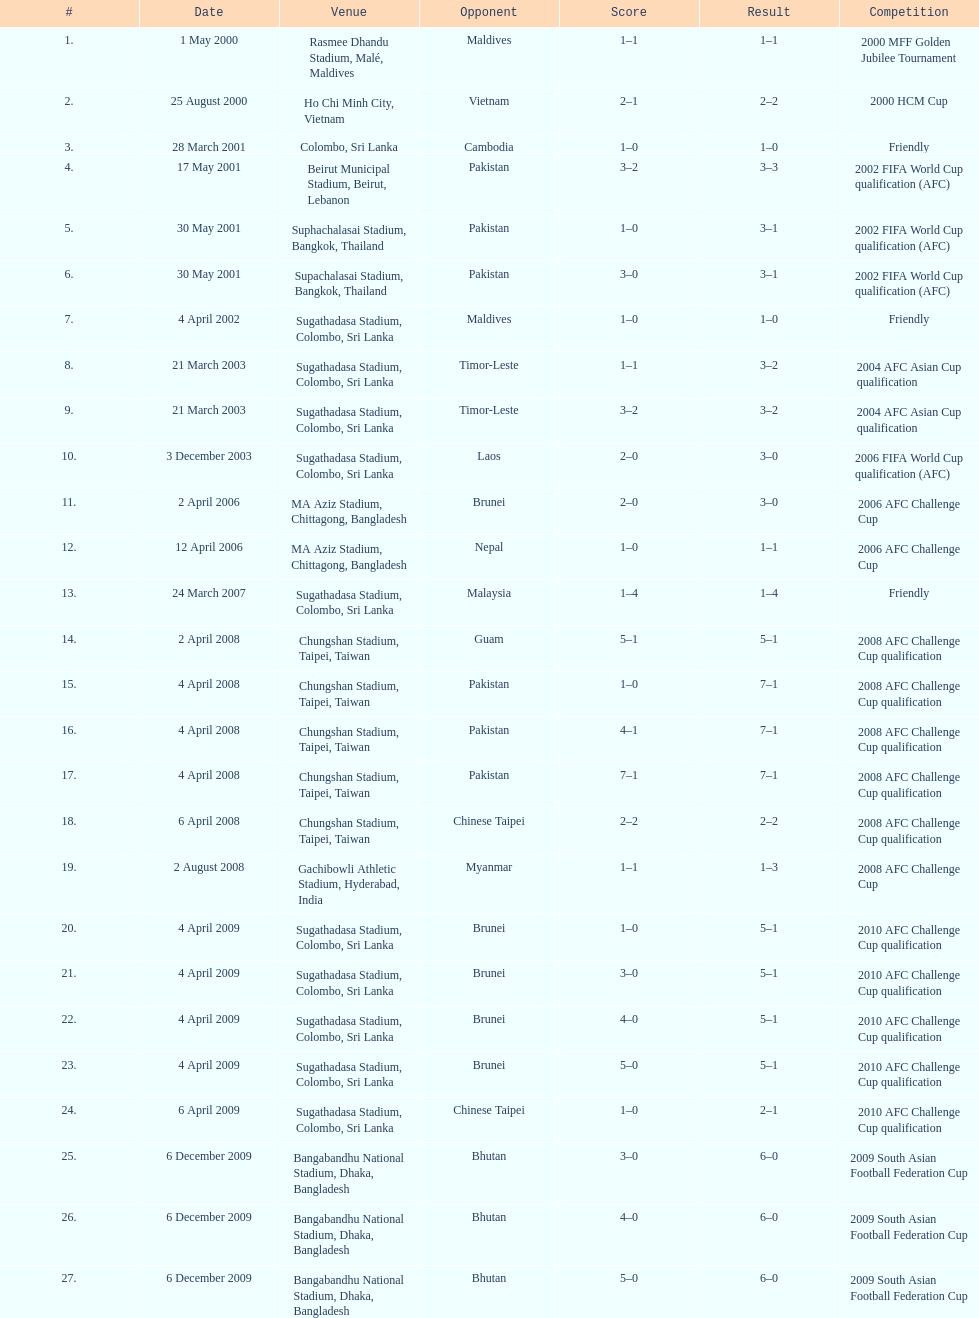Were more competitions played in april or december? April. 